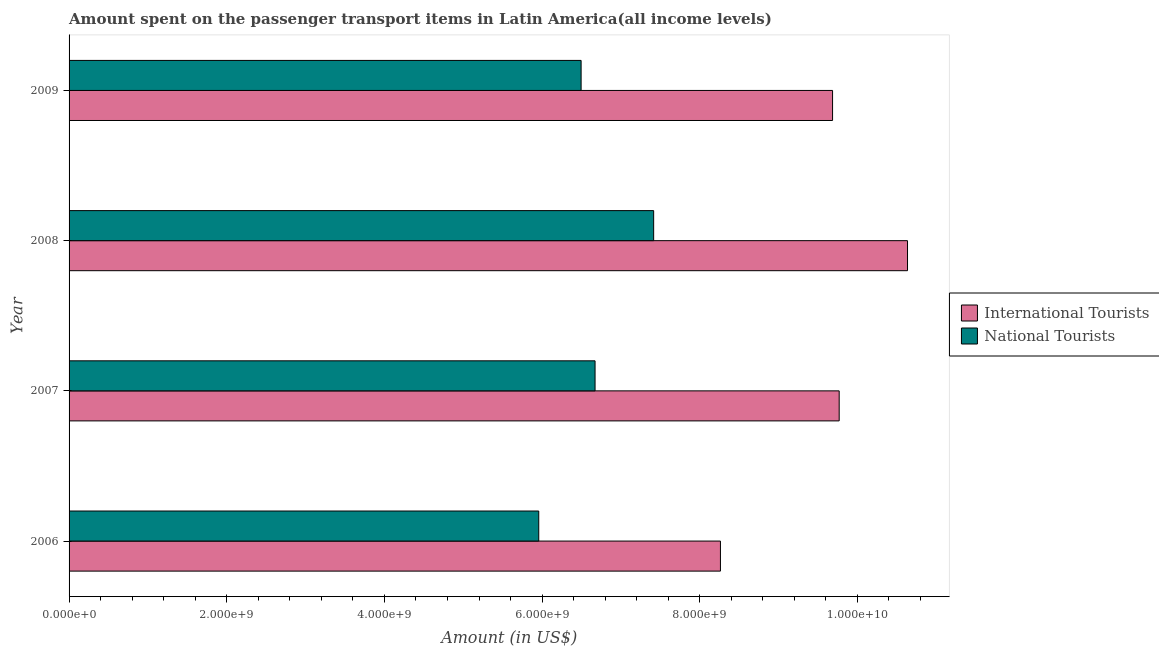How many different coloured bars are there?
Your answer should be very brief. 2. How many groups of bars are there?
Give a very brief answer. 4. Are the number of bars on each tick of the Y-axis equal?
Make the answer very short. Yes. How many bars are there on the 1st tick from the top?
Your response must be concise. 2. How many bars are there on the 3rd tick from the bottom?
Your answer should be compact. 2. In how many cases, is the number of bars for a given year not equal to the number of legend labels?
Provide a succinct answer. 0. What is the amount spent on transport items of national tourists in 2009?
Make the answer very short. 6.49e+09. Across all years, what is the maximum amount spent on transport items of national tourists?
Offer a terse response. 7.41e+09. Across all years, what is the minimum amount spent on transport items of national tourists?
Keep it short and to the point. 5.96e+09. In which year was the amount spent on transport items of international tourists maximum?
Provide a short and direct response. 2008. In which year was the amount spent on transport items of international tourists minimum?
Your response must be concise. 2006. What is the total amount spent on transport items of national tourists in the graph?
Keep it short and to the point. 2.65e+1. What is the difference between the amount spent on transport items of national tourists in 2008 and that in 2009?
Ensure brevity in your answer.  9.20e+08. What is the difference between the amount spent on transport items of international tourists in 2009 and the amount spent on transport items of national tourists in 2007?
Provide a short and direct response. 3.01e+09. What is the average amount spent on transport items of national tourists per year?
Ensure brevity in your answer.  6.63e+09. In the year 2006, what is the difference between the amount spent on transport items of national tourists and amount spent on transport items of international tourists?
Provide a short and direct response. -2.30e+09. What is the ratio of the amount spent on transport items of national tourists in 2006 to that in 2009?
Provide a succinct answer. 0.92. Is the difference between the amount spent on transport items of national tourists in 2008 and 2009 greater than the difference between the amount spent on transport items of international tourists in 2008 and 2009?
Keep it short and to the point. No. What is the difference between the highest and the second highest amount spent on transport items of national tourists?
Ensure brevity in your answer.  7.43e+08. What is the difference between the highest and the lowest amount spent on transport items of international tourists?
Make the answer very short. 2.37e+09. What does the 1st bar from the top in 2006 represents?
Provide a succinct answer. National Tourists. What does the 2nd bar from the bottom in 2008 represents?
Make the answer very short. National Tourists. Does the graph contain any zero values?
Keep it short and to the point. No. What is the title of the graph?
Ensure brevity in your answer.  Amount spent on the passenger transport items in Latin America(all income levels). Does "Nitrous oxide" appear as one of the legend labels in the graph?
Make the answer very short. No. What is the label or title of the Y-axis?
Provide a succinct answer. Year. What is the Amount (in US$) of International Tourists in 2006?
Your answer should be compact. 8.26e+09. What is the Amount (in US$) in National Tourists in 2006?
Ensure brevity in your answer.  5.96e+09. What is the Amount (in US$) in International Tourists in 2007?
Ensure brevity in your answer.  9.77e+09. What is the Amount (in US$) of National Tourists in 2007?
Ensure brevity in your answer.  6.67e+09. What is the Amount (in US$) of International Tourists in 2008?
Give a very brief answer. 1.06e+1. What is the Amount (in US$) of National Tourists in 2008?
Your response must be concise. 7.41e+09. What is the Amount (in US$) of International Tourists in 2009?
Give a very brief answer. 9.68e+09. What is the Amount (in US$) of National Tourists in 2009?
Give a very brief answer. 6.49e+09. Across all years, what is the maximum Amount (in US$) in International Tourists?
Give a very brief answer. 1.06e+1. Across all years, what is the maximum Amount (in US$) in National Tourists?
Your answer should be very brief. 7.41e+09. Across all years, what is the minimum Amount (in US$) in International Tourists?
Your answer should be compact. 8.26e+09. Across all years, what is the minimum Amount (in US$) in National Tourists?
Your answer should be compact. 5.96e+09. What is the total Amount (in US$) of International Tourists in the graph?
Give a very brief answer. 3.83e+1. What is the total Amount (in US$) in National Tourists in the graph?
Offer a terse response. 2.65e+1. What is the difference between the Amount (in US$) in International Tourists in 2006 and that in 2007?
Your answer should be very brief. -1.51e+09. What is the difference between the Amount (in US$) of National Tourists in 2006 and that in 2007?
Keep it short and to the point. -7.14e+08. What is the difference between the Amount (in US$) of International Tourists in 2006 and that in 2008?
Your answer should be compact. -2.37e+09. What is the difference between the Amount (in US$) in National Tourists in 2006 and that in 2008?
Make the answer very short. -1.46e+09. What is the difference between the Amount (in US$) of International Tourists in 2006 and that in 2009?
Offer a very short reply. -1.42e+09. What is the difference between the Amount (in US$) in National Tourists in 2006 and that in 2009?
Offer a terse response. -5.37e+08. What is the difference between the Amount (in US$) of International Tourists in 2007 and that in 2008?
Offer a very short reply. -8.67e+08. What is the difference between the Amount (in US$) of National Tourists in 2007 and that in 2008?
Ensure brevity in your answer.  -7.43e+08. What is the difference between the Amount (in US$) in International Tourists in 2007 and that in 2009?
Give a very brief answer. 8.40e+07. What is the difference between the Amount (in US$) of National Tourists in 2007 and that in 2009?
Your answer should be very brief. 1.77e+08. What is the difference between the Amount (in US$) in International Tourists in 2008 and that in 2009?
Your response must be concise. 9.51e+08. What is the difference between the Amount (in US$) in National Tourists in 2008 and that in 2009?
Offer a very short reply. 9.20e+08. What is the difference between the Amount (in US$) in International Tourists in 2006 and the Amount (in US$) in National Tourists in 2007?
Your answer should be very brief. 1.59e+09. What is the difference between the Amount (in US$) of International Tourists in 2006 and the Amount (in US$) of National Tourists in 2008?
Provide a short and direct response. 8.47e+08. What is the difference between the Amount (in US$) in International Tourists in 2006 and the Amount (in US$) in National Tourists in 2009?
Provide a short and direct response. 1.77e+09. What is the difference between the Amount (in US$) in International Tourists in 2007 and the Amount (in US$) in National Tourists in 2008?
Your response must be concise. 2.35e+09. What is the difference between the Amount (in US$) in International Tourists in 2007 and the Amount (in US$) in National Tourists in 2009?
Give a very brief answer. 3.27e+09. What is the difference between the Amount (in US$) in International Tourists in 2008 and the Amount (in US$) in National Tourists in 2009?
Make the answer very short. 4.14e+09. What is the average Amount (in US$) in International Tourists per year?
Give a very brief answer. 9.59e+09. What is the average Amount (in US$) in National Tourists per year?
Provide a succinct answer. 6.63e+09. In the year 2006, what is the difference between the Amount (in US$) of International Tourists and Amount (in US$) of National Tourists?
Give a very brief answer. 2.30e+09. In the year 2007, what is the difference between the Amount (in US$) of International Tourists and Amount (in US$) of National Tourists?
Your response must be concise. 3.10e+09. In the year 2008, what is the difference between the Amount (in US$) of International Tourists and Amount (in US$) of National Tourists?
Make the answer very short. 3.22e+09. In the year 2009, what is the difference between the Amount (in US$) in International Tourists and Amount (in US$) in National Tourists?
Make the answer very short. 3.19e+09. What is the ratio of the Amount (in US$) of International Tourists in 2006 to that in 2007?
Keep it short and to the point. 0.85. What is the ratio of the Amount (in US$) in National Tourists in 2006 to that in 2007?
Keep it short and to the point. 0.89. What is the ratio of the Amount (in US$) in International Tourists in 2006 to that in 2008?
Offer a terse response. 0.78. What is the ratio of the Amount (in US$) in National Tourists in 2006 to that in 2008?
Your answer should be compact. 0.8. What is the ratio of the Amount (in US$) in International Tourists in 2006 to that in 2009?
Ensure brevity in your answer.  0.85. What is the ratio of the Amount (in US$) of National Tourists in 2006 to that in 2009?
Your answer should be compact. 0.92. What is the ratio of the Amount (in US$) in International Tourists in 2007 to that in 2008?
Ensure brevity in your answer.  0.92. What is the ratio of the Amount (in US$) in National Tourists in 2007 to that in 2008?
Give a very brief answer. 0.9. What is the ratio of the Amount (in US$) in International Tourists in 2007 to that in 2009?
Give a very brief answer. 1.01. What is the ratio of the Amount (in US$) of National Tourists in 2007 to that in 2009?
Offer a terse response. 1.03. What is the ratio of the Amount (in US$) in International Tourists in 2008 to that in 2009?
Provide a succinct answer. 1.1. What is the ratio of the Amount (in US$) in National Tourists in 2008 to that in 2009?
Make the answer very short. 1.14. What is the difference between the highest and the second highest Amount (in US$) of International Tourists?
Offer a very short reply. 8.67e+08. What is the difference between the highest and the second highest Amount (in US$) in National Tourists?
Keep it short and to the point. 7.43e+08. What is the difference between the highest and the lowest Amount (in US$) in International Tourists?
Keep it short and to the point. 2.37e+09. What is the difference between the highest and the lowest Amount (in US$) of National Tourists?
Your answer should be very brief. 1.46e+09. 